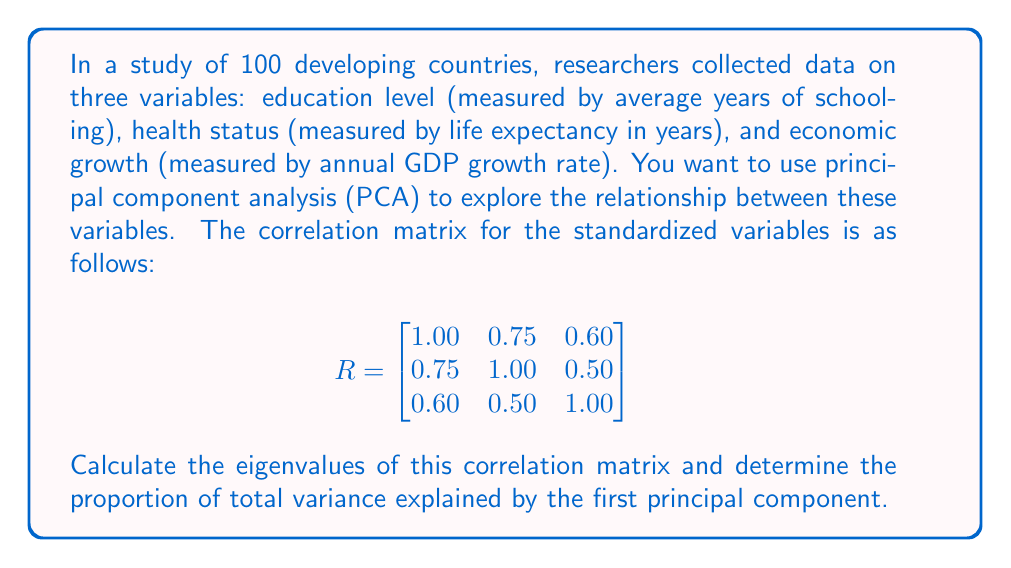Could you help me with this problem? To solve this problem, we'll follow these steps:

1) First, we need to find the eigenvalues of the correlation matrix. The characteristic equation is:

   $$det(R - \lambda I) = 0$$

   where $I$ is the 3x3 identity matrix and $\lambda$ represents the eigenvalues.

2) Expanding this determinant:

   $$
   \begin{vmatrix}
   1-\lambda & 0.75 & 0.60 \\
   0.75 & 1-\lambda & 0.50 \\
   0.60 & 0.50 & 1-\lambda
   \end{vmatrix} = 0
   $$

3) This expands to the cubic equation:

   $$-\lambda^3 + 3\lambda^2 - 2.0375\lambda + 0.2775 = 0$$

4) Solving this equation (usually with computational aid) gives us the eigenvalues:

   $$\lambda_1 \approx 2.1775, \lambda_2 \approx 0.5450, \lambda_3 \approx 0.2775$$

5) The total variance in a PCA of a correlation matrix is always equal to the number of variables, which in this case is 3.

6) The proportion of variance explained by the first principal component is the largest eigenvalue divided by the total variance:

   $$\frac{\lambda_1}{3} = \frac{2.1775}{3} \approx 0.7258$$

Therefore, the first principal component explains approximately 72.58% of the total variance.
Answer: The eigenvalues are approximately 2.1775, 0.5450, and 0.2775. The proportion of total variance explained by the first principal component is approximately 0.7258 or 72.58%. 